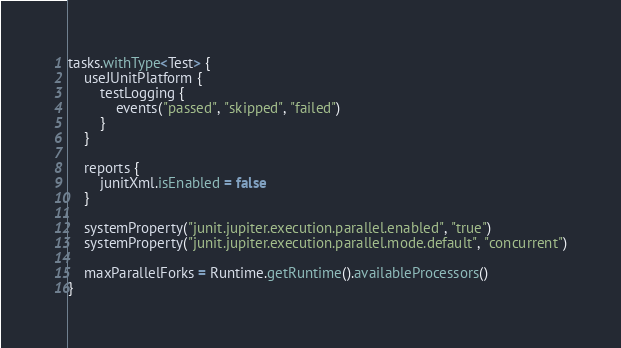<code> <loc_0><loc_0><loc_500><loc_500><_Kotlin_>tasks.withType<Test> {
	useJUnitPlatform {
		testLogging {
			events("passed", "skipped", "failed")
		}
	}

	reports {
		junitXml.isEnabled = false
	}

	systemProperty("junit.jupiter.execution.parallel.enabled", "true")
	systemProperty("junit.jupiter.execution.parallel.mode.default", "concurrent")

	maxParallelForks = Runtime.getRuntime().availableProcessors()
}
</code> 